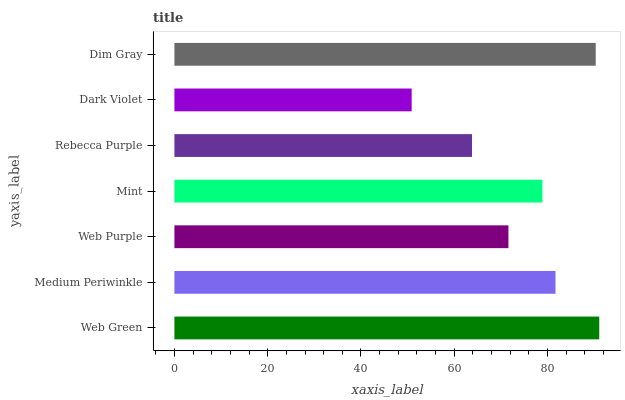Is Dark Violet the minimum?
Answer yes or no. Yes. Is Web Green the maximum?
Answer yes or no. Yes. Is Medium Periwinkle the minimum?
Answer yes or no. No. Is Medium Periwinkle the maximum?
Answer yes or no. No. Is Web Green greater than Medium Periwinkle?
Answer yes or no. Yes. Is Medium Periwinkle less than Web Green?
Answer yes or no. Yes. Is Medium Periwinkle greater than Web Green?
Answer yes or no. No. Is Web Green less than Medium Periwinkle?
Answer yes or no. No. Is Mint the high median?
Answer yes or no. Yes. Is Mint the low median?
Answer yes or no. Yes. Is Web Green the high median?
Answer yes or no. No. Is Web Purple the low median?
Answer yes or no. No. 